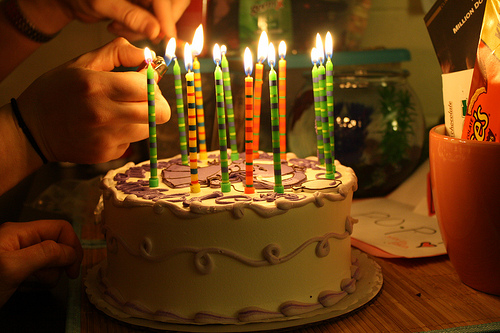<image>
Is there a cake on the table? Yes. Looking at the image, I can see the cake is positioned on top of the table, with the table providing support. Is there a candle on the table? No. The candle is not positioned on the table. They may be near each other, but the candle is not supported by or resting on top of the table. Where is the candle in relation to the man? Is it on the man? No. The candle is not positioned on the man. They may be near each other, but the candle is not supported by or resting on top of the man. Where is the cake in relation to the handle? Is it on the handle? No. The cake is not positioned on the handle. They may be near each other, but the cake is not supported by or resting on top of the handle. Is the pot under the shelf? Yes. The pot is positioned underneath the shelf, with the shelf above it in the vertical space. 